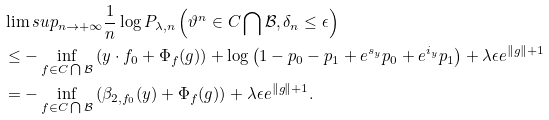Convert formula to latex. <formula><loc_0><loc_0><loc_500><loc_500>& \lim s u p _ { n \rightarrow + \infty } \frac { 1 } { n } \log P _ { \lambda , n } \left ( \vartheta ^ { n } \in C \bigcap \mathcal { B } , \delta _ { n } \leq \epsilon \right ) \\ & \leq - \inf _ { f \in C \bigcap \mathcal { B } } \left ( y \cdot f _ { 0 } + \Phi _ { f } ( g ) \right ) + \log \left ( 1 - p _ { 0 } - p _ { 1 } + e ^ { s _ { y } } p _ { 0 } + e ^ { i _ { y } } p _ { 1 } \right ) + \lambda \epsilon e ^ { \| g \| + 1 } \\ & = - \inf _ { f \in C \bigcap \mathcal { B } } \left ( \beta _ { 2 , f _ { 0 } } ( y ) + \Phi _ { f } ( g ) \right ) + \lambda \epsilon e ^ { \| g \| + 1 } .</formula> 